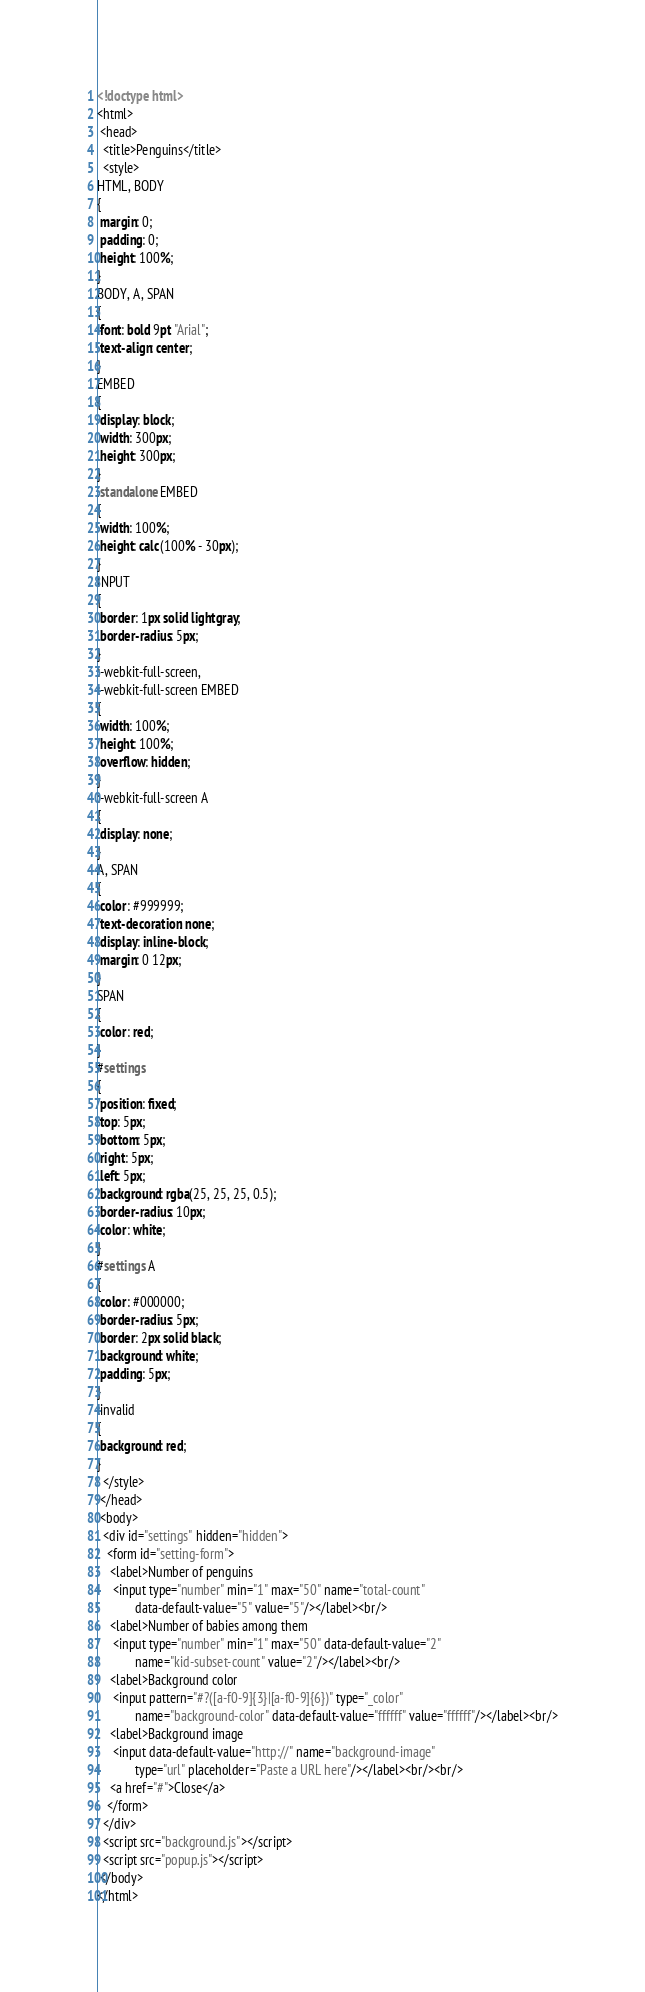<code> <loc_0><loc_0><loc_500><loc_500><_HTML_><!doctype html>
<html>
 <head>
  <title>Penguins</title>
  <style>
HTML, BODY
{
 margin: 0;
 padding: 0;
 height: 100%;
}
BODY, A, SPAN
{
 font: bold 9pt "Arial";
 text-align: center;
}
EMBED
{
 display: block;
 width: 300px;
 height: 300px;
}
.standalone EMBED
{
 width: 100%;
 height: calc(100% - 30px);
}
INPUT
{
 border: 1px solid lightgray;
 border-radius: 5px;
}
:-webkit-full-screen,
:-webkit-full-screen EMBED
{
 width: 100%;
 height: 100%;
 overflow: hidden;
}
:-webkit-full-screen A
{
 display: none;
}
A, SPAN
{
 color: #999999;
 text-decoration: none;
 display: inline-block;
 margin: 0 12px;
}
SPAN
{
 color: red;
}
#settings
{
 position: fixed;
 top: 5px;
 bottom: 5px;
 right: 5px;
 left: 5px;
 background: rgba(25, 25, 25, 0.5);
 border-radius: 10px;
 color: white;
}
#settings A
{
 color: #000000;
 border-radius: 5px;
 border: 2px solid black;
 background: white;
 padding: 5px;
}
:invalid
{
 background: red;
}
  </style>
 </head>
 <body>
  <div id="settings" hidden="hidden">
   <form id="setting-form">
    <label>Number of penguins
     <input type="number" min="1" max="50" name="total-count"
            data-default-value="5" value="5"/></label><br/>
    <label>Number of babies among them
     <input type="number" min="1" max="50" data-default-value="2"
            name="kid-subset-count" value="2"/></label><br/>
    <label>Background color
     <input pattern="#?([a-f0-9]{3}|[a-f0-9]{6})" type="_color"
            name="background-color" data-default-value="ffffff" value="ffffff"/></label><br/>
    <label>Background image
     <input data-default-value="http://" name="background-image"
            type="url" placeholder="Paste a URL here"/></label><br/><br/>
    <a href="#">Close</a>
   </form>
  </div>
  <script src="background.js"></script>
  <script src="popup.js"></script>
 </body>
</html></code> 